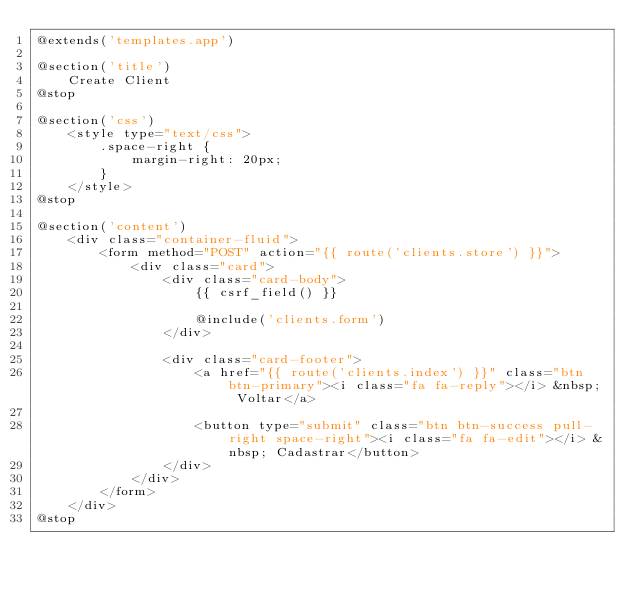<code> <loc_0><loc_0><loc_500><loc_500><_PHP_>@extends('templates.app')

@section('title')
    Create Client
@stop

@section('css')
    <style type="text/css">
        .space-right {
            margin-right: 20px;
        }
    </style>
@stop

@section('content')
    <div class="container-fluid">
        <form method="POST" action="{{ route('clients.store') }}">
            <div class="card">
                <div class="card-body">
                    {{ csrf_field() }}

                    @include('clients.form')
                </div>

                <div class="card-footer">
                    <a href="{{ route('clients.index') }}" class="btn btn-primary"><i class="fa fa-reply"></i> &nbsp; Voltar</a>

                    <button type="submit" class="btn btn-success pull-right space-right"><i class="fa fa-edit"></i> &nbsp; Cadastrar</button>
                </div>
            </div>
        </form>
    </div>
@stop
</code> 